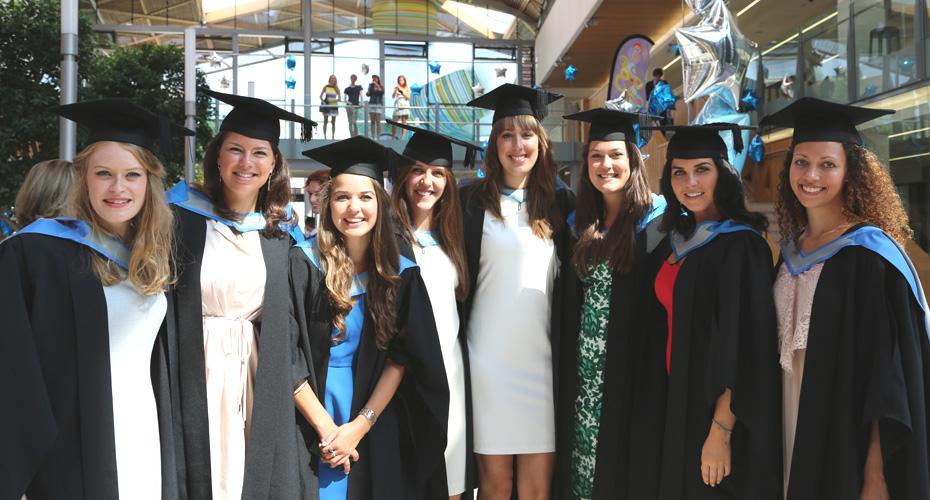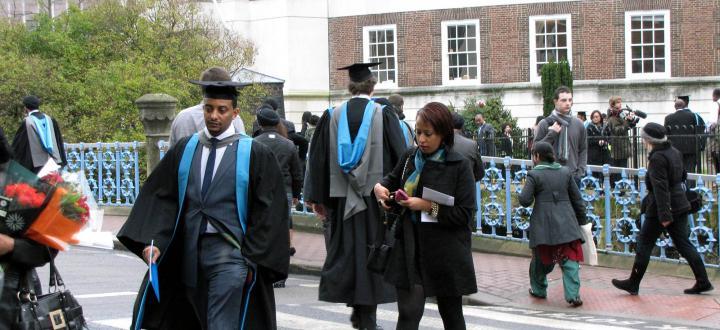The first image is the image on the left, the second image is the image on the right. Examine the images to the left and right. Is the description "The left image shows a group of four people." accurate? Answer yes or no. No. 